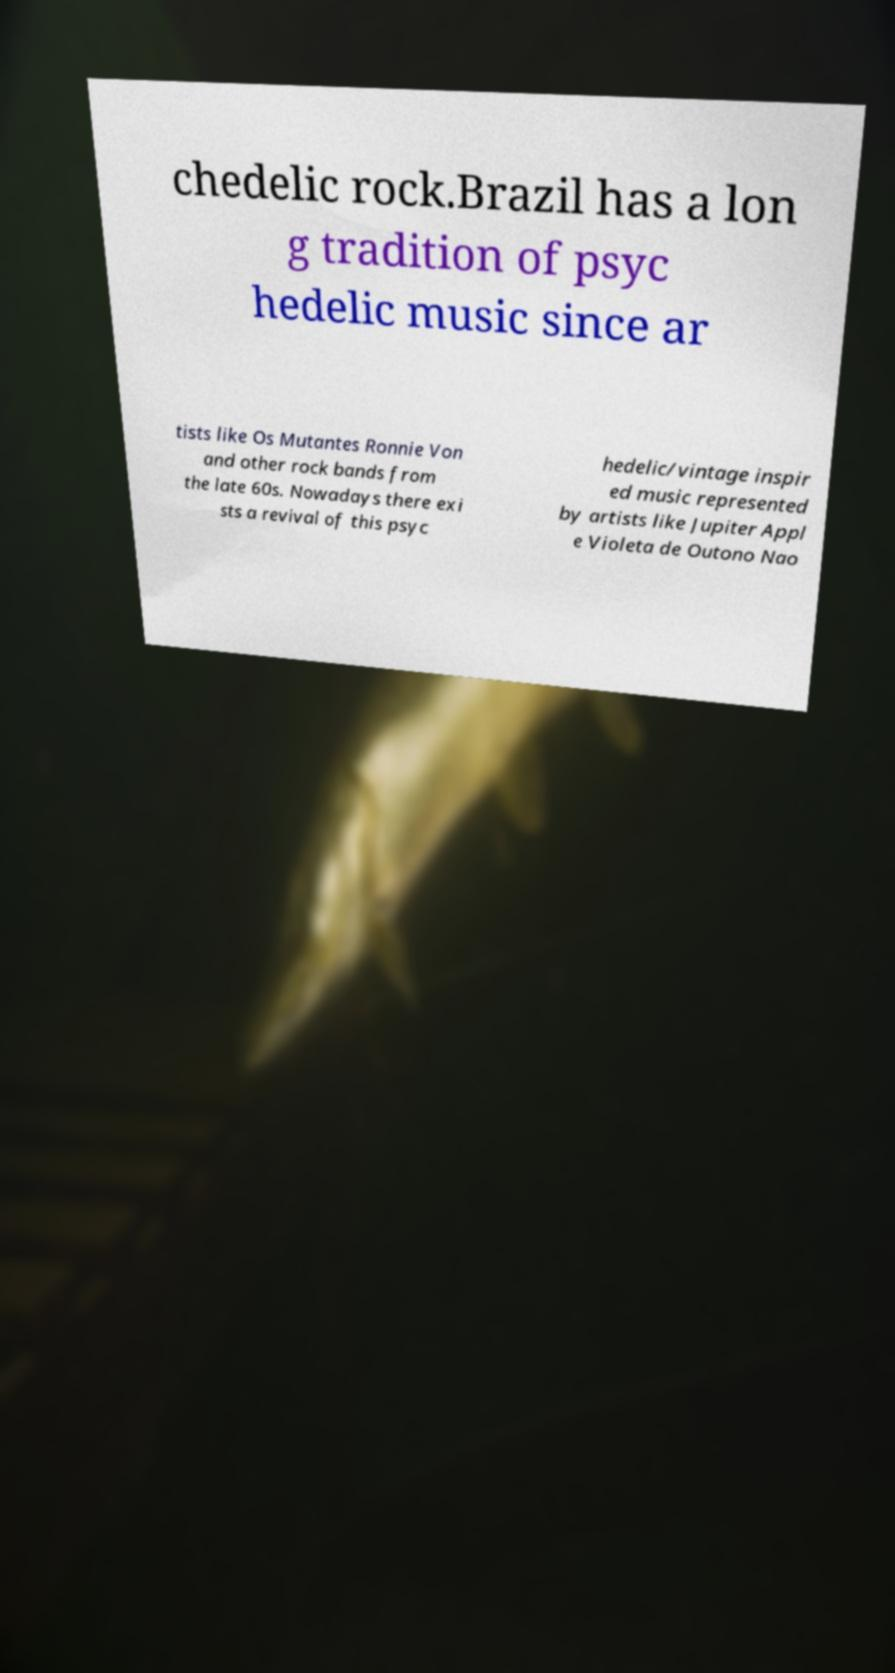Could you assist in decoding the text presented in this image and type it out clearly? chedelic rock.Brazil has a lon g tradition of psyc hedelic music since ar tists like Os Mutantes Ronnie Von and other rock bands from the late 60s. Nowadays there exi sts a revival of this psyc hedelic/vintage inspir ed music represented by artists like Jupiter Appl e Violeta de Outono Nao 